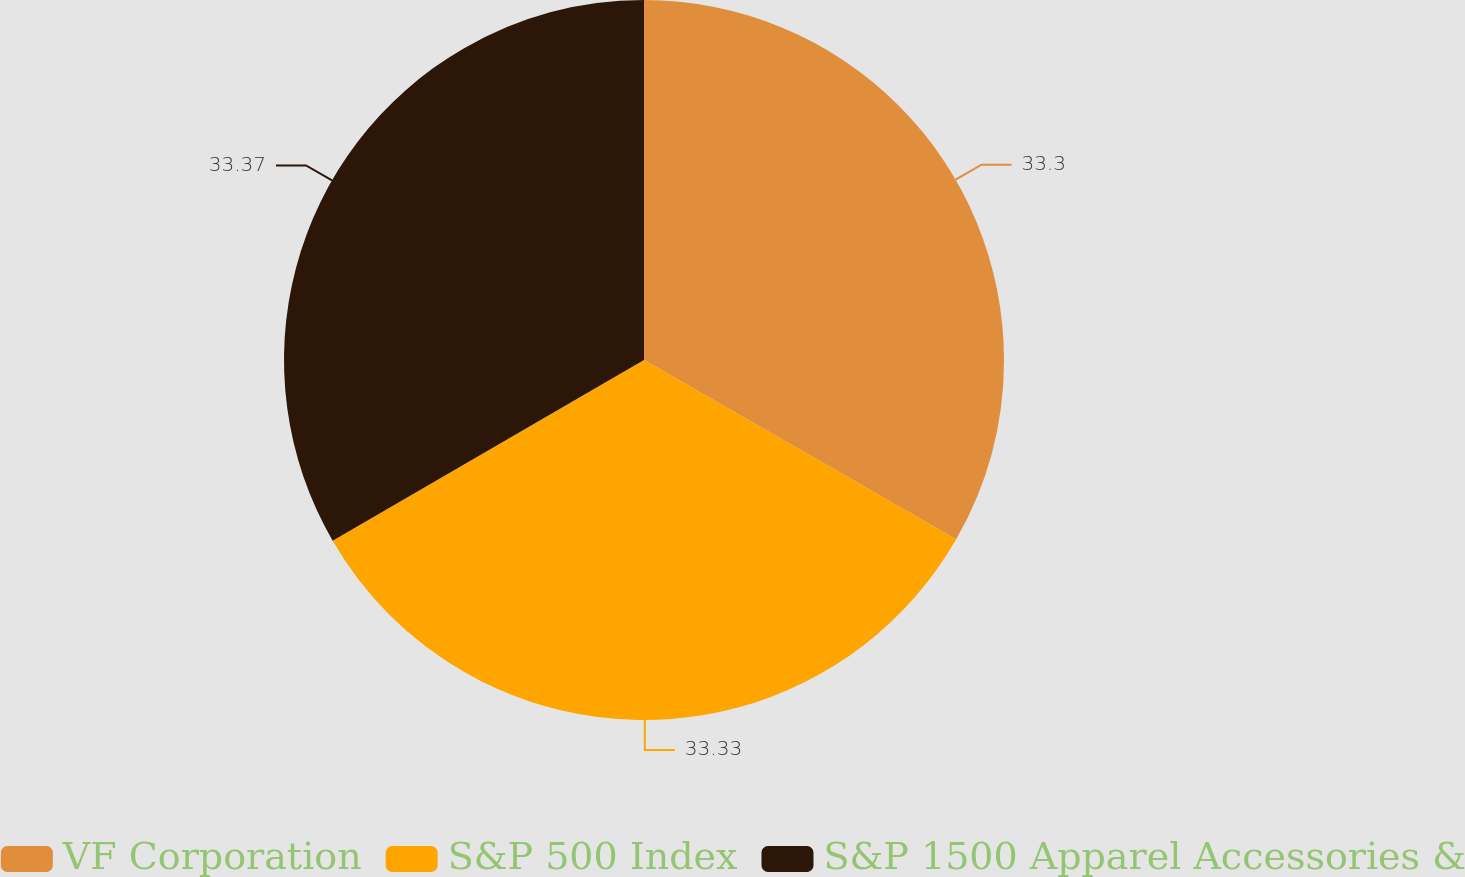Convert chart to OTSL. <chart><loc_0><loc_0><loc_500><loc_500><pie_chart><fcel>VF Corporation<fcel>S&P 500 Index<fcel>S&P 1500 Apparel Accessories &<nl><fcel>33.3%<fcel>33.33%<fcel>33.37%<nl></chart> 